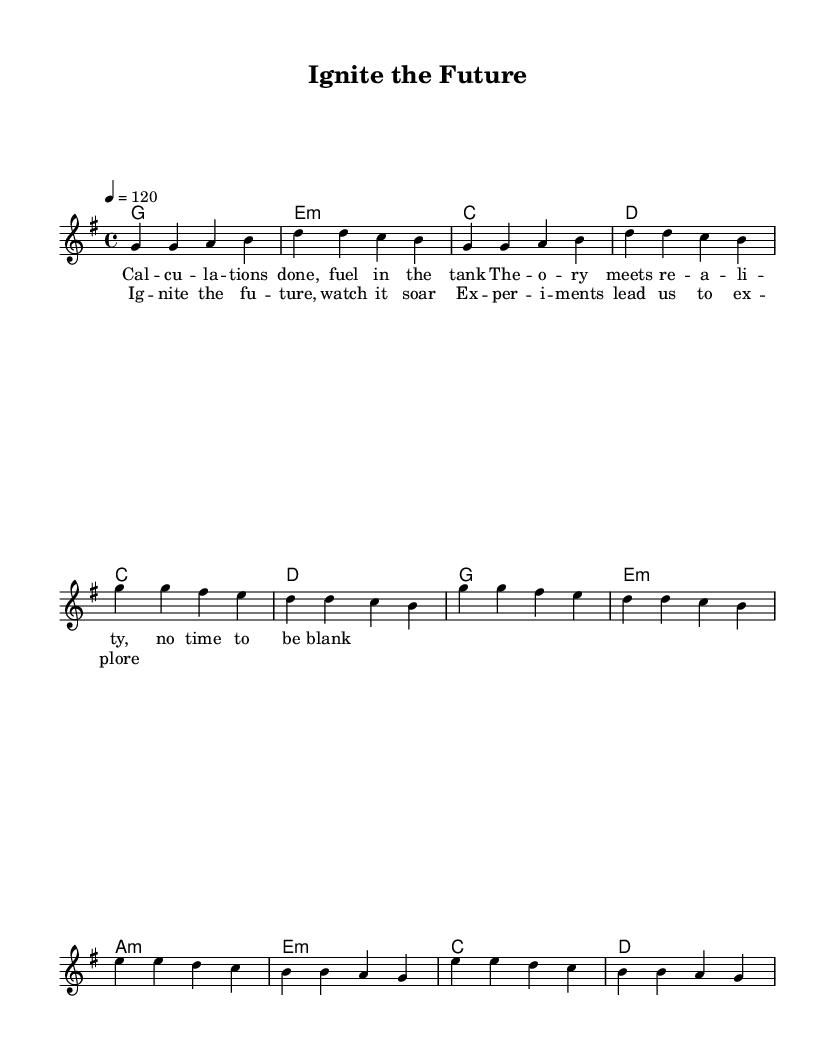What is the key signature of this music? The key signature is G major, which has one sharp (F#). This is indicated at the beginning of the sheet music, where the key is written.
Answer: G major What is the time signature of this piece? The time signature is 4/4, which means there are four beats in each measure and a quarter note gets one beat. This can be seen in the time signature indication at the start of the sheet music.
Answer: 4/4 What is the tempo marking for the piece? The tempo marking is 120 beats per minute, stated in the tempo section at the beginning. This indicates how fast the music should be played.
Answer: 120 How many measures are in the verse section? The verse section consists of 4 measures, as counted by the groups of notes divided by the bar lines in the melody section.
Answer: 4 What are the chord names for the chorus? The chord names for the chorus are C, D, G, and E minor, listed in the chord names section above the melody. This shows the harmonic structure accompanying the lyrics of the chorus.
Answer: C, D, G, E minor What lyrical theme does the chorus convey? The chorus conveys themes of excitement and exploration, as indicated by the lyrics expressing the ignition of the future and the adventure of experimentation. This is derived from the words in the chorus section.
Answer: Excitement and exploration What type of song structure does this piece follow? The piece follows a common song structure of verse-chorus, as demonstrated by the layout with a distinct verse section followed by a chorus. This structure is typical for Rhythm and Blues music to create repetitive, engaging elements.
Answer: Verse-chorus 